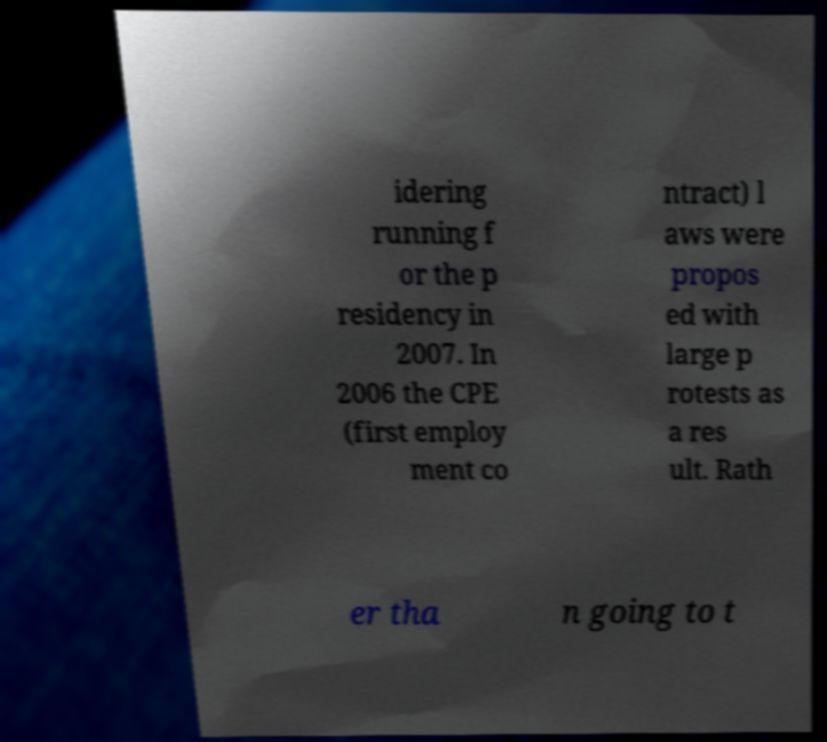Can you accurately transcribe the text from the provided image for me? idering running f or the p residency in 2007. In 2006 the CPE (first employ ment co ntract) l aws were propos ed with large p rotests as a res ult. Rath er tha n going to t 